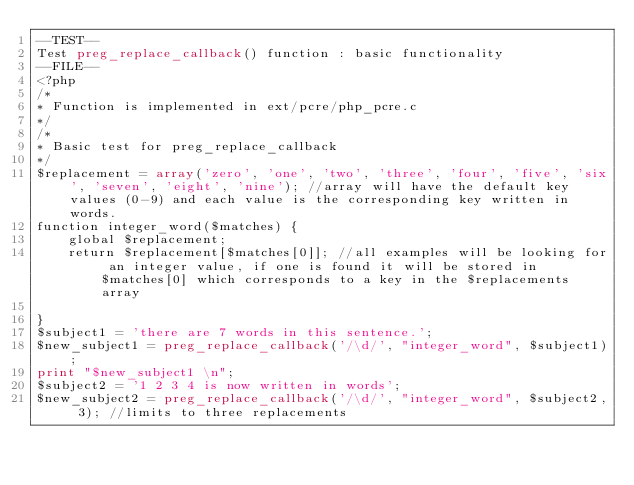Convert code to text. <code><loc_0><loc_0><loc_500><loc_500><_PHP_>--TEST--
Test preg_replace_callback() function : basic functionality
--FILE--
<?php
/*
* Function is implemented in ext/pcre/php_pcre.c
*/
/*
* Basic test for preg_replace_callback
*/
$replacement = array('zero', 'one', 'two', 'three', 'four', 'five', 'six', 'seven', 'eight', 'nine'); //array will have the default key values (0-9) and each value is the corresponding key written in words.
function integer_word($matches) {
    global $replacement;
    return $replacement[$matches[0]]; //all examples will be looking for an integer value, if one is found it will be stored in $matches[0] which corresponds to a key in the $replacements array

}
$subject1 = 'there are 7 words in this sentence.';
$new_subject1 = preg_replace_callback('/\d/', "integer_word", $subject1);
print "$new_subject1 \n";
$subject2 = '1 2 3 4 is now written in words';
$new_subject2 = preg_replace_callback('/\d/', "integer_word", $subject2, 3); //limits to three replacements</code> 